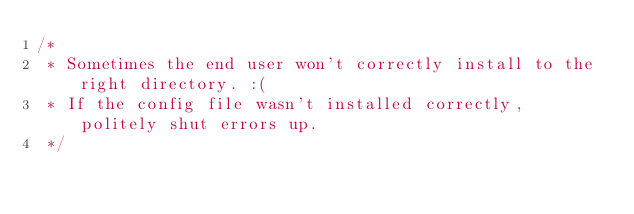<code> <loc_0><loc_0><loc_500><loc_500><_C_>/*
 * Sometimes the end user won't correctly install to the right directory. :(
 * If the config file wasn't installed correctly, politely shut errors up.
 */</code> 